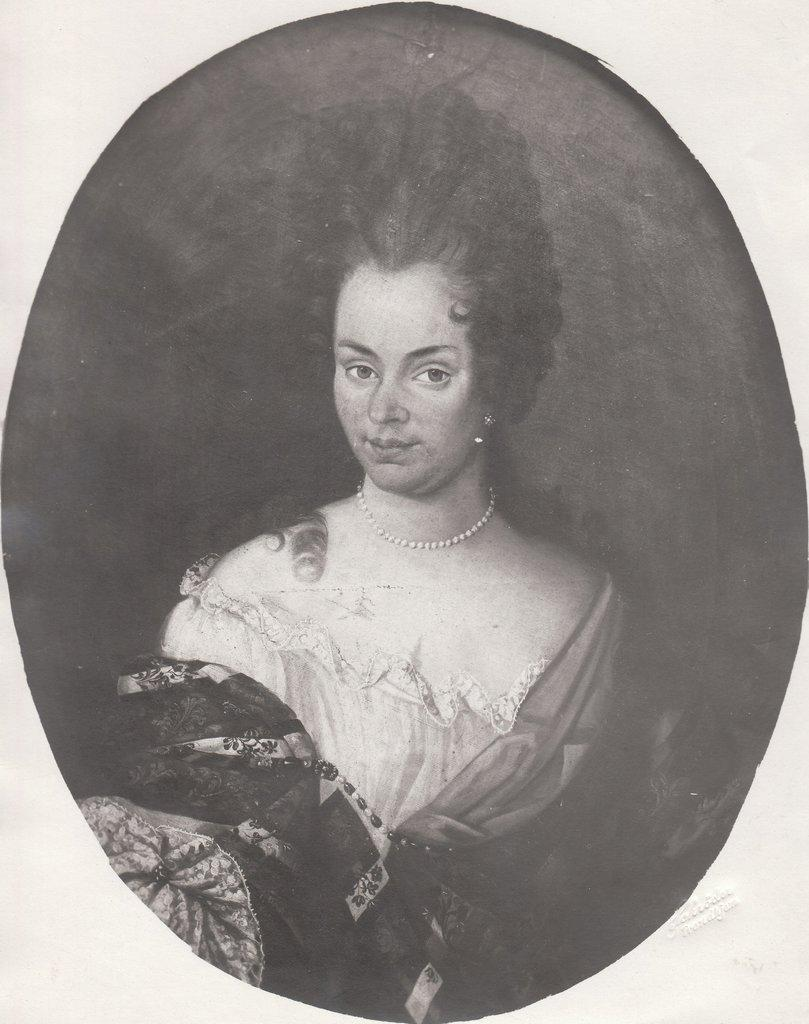What is the main subject of the image? There is a picture of a woman in the image. Where is the woman positioned in the image? The woman is standing in the middle of the image. What type of skin condition does the woman have in the image? There is no indication of any skin condition in the image; it only shows a woman standing in the middle. 